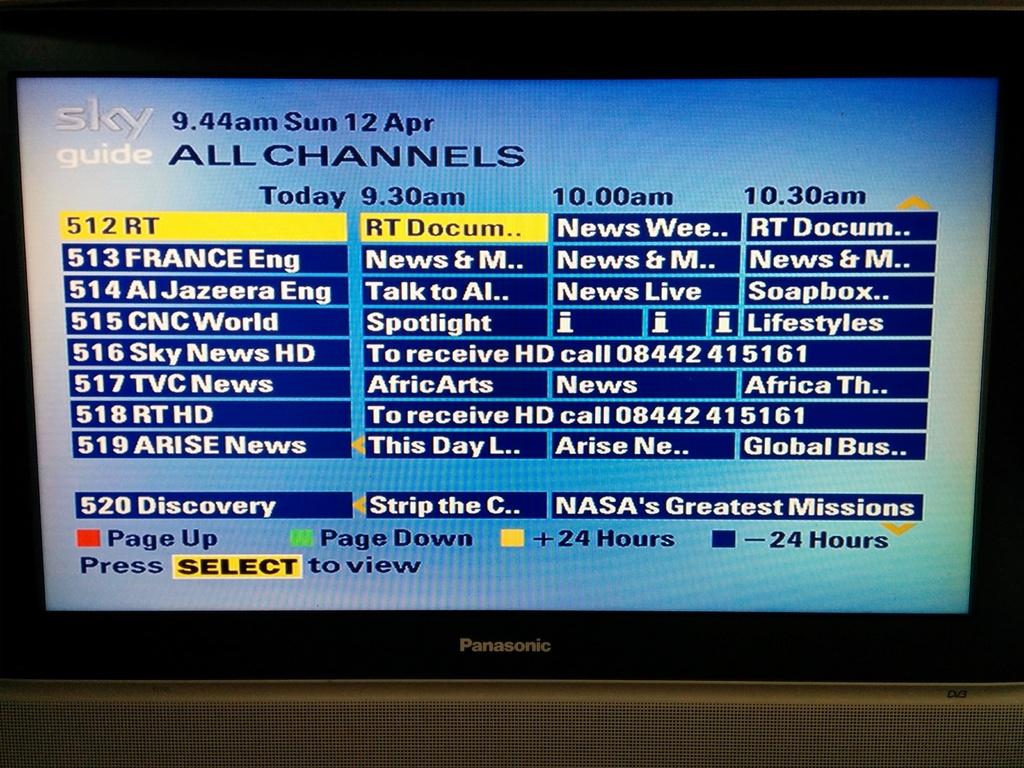What day of the week was this phto taken?
Offer a very short reply. Sunday. What is the last time of shows shown?
Make the answer very short. 10:30am. 